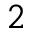Convert formula to latex. <formula><loc_0><loc_0><loc_500><loc_500>2</formula> 